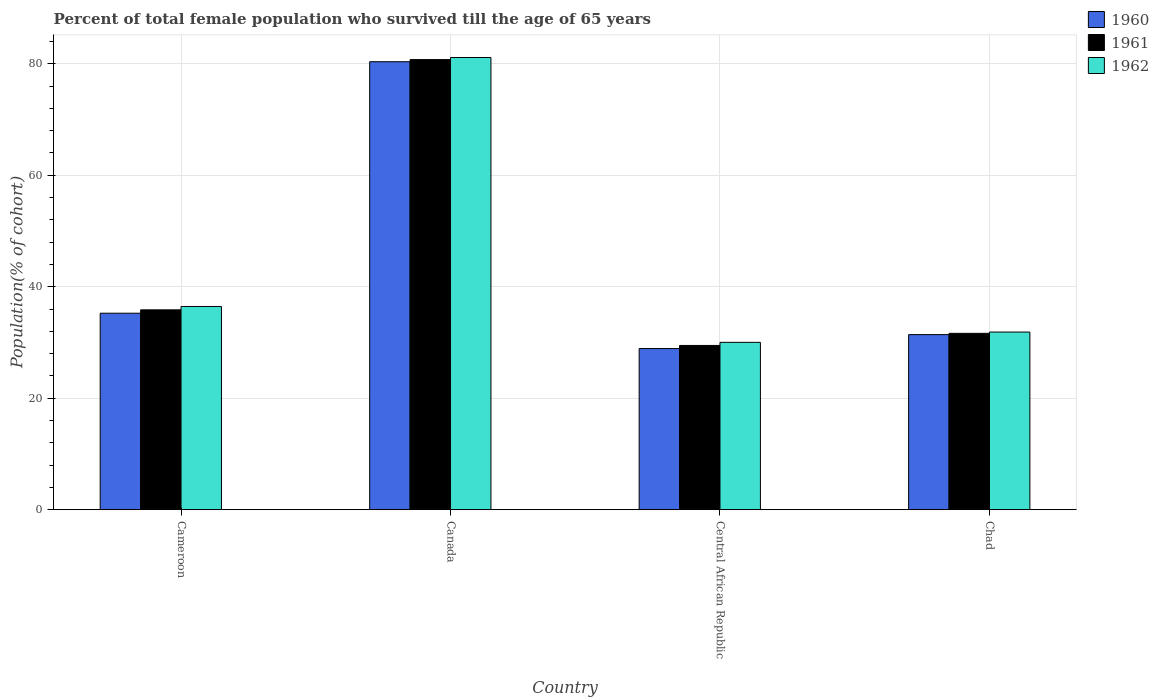How many different coloured bars are there?
Your answer should be compact. 3. How many groups of bars are there?
Your answer should be very brief. 4. How many bars are there on the 3rd tick from the left?
Ensure brevity in your answer.  3. How many bars are there on the 3rd tick from the right?
Ensure brevity in your answer.  3. What is the label of the 3rd group of bars from the left?
Keep it short and to the point. Central African Republic. In how many cases, is the number of bars for a given country not equal to the number of legend labels?
Make the answer very short. 0. What is the percentage of total female population who survived till the age of 65 years in 1961 in Central African Republic?
Ensure brevity in your answer.  29.47. Across all countries, what is the maximum percentage of total female population who survived till the age of 65 years in 1960?
Offer a terse response. 80.38. Across all countries, what is the minimum percentage of total female population who survived till the age of 65 years in 1961?
Ensure brevity in your answer.  29.47. In which country was the percentage of total female population who survived till the age of 65 years in 1960 minimum?
Make the answer very short. Central African Republic. What is the total percentage of total female population who survived till the age of 65 years in 1962 in the graph?
Provide a succinct answer. 179.5. What is the difference between the percentage of total female population who survived till the age of 65 years in 1961 in Cameroon and that in Central African Republic?
Your response must be concise. 6.39. What is the difference between the percentage of total female population who survived till the age of 65 years in 1960 in Chad and the percentage of total female population who survived till the age of 65 years in 1961 in Cameroon?
Make the answer very short. -4.44. What is the average percentage of total female population who survived till the age of 65 years in 1961 per country?
Offer a terse response. 44.43. What is the difference between the percentage of total female population who survived till the age of 65 years of/in 1960 and percentage of total female population who survived till the age of 65 years of/in 1962 in Cameroon?
Offer a terse response. -1.21. In how many countries, is the percentage of total female population who survived till the age of 65 years in 1961 greater than 12 %?
Your answer should be very brief. 4. What is the ratio of the percentage of total female population who survived till the age of 65 years in 1961 in Central African Republic to that in Chad?
Your answer should be very brief. 0.93. Is the percentage of total female population who survived till the age of 65 years in 1962 in Canada less than that in Chad?
Your answer should be compact. No. Is the difference between the percentage of total female population who survived till the age of 65 years in 1960 in Cameroon and Chad greater than the difference between the percentage of total female population who survived till the age of 65 years in 1962 in Cameroon and Chad?
Provide a succinct answer. No. What is the difference between the highest and the second highest percentage of total female population who survived till the age of 65 years in 1962?
Your answer should be compact. 44.67. What is the difference between the highest and the lowest percentage of total female population who survived till the age of 65 years in 1961?
Keep it short and to the point. 51.29. In how many countries, is the percentage of total female population who survived till the age of 65 years in 1960 greater than the average percentage of total female population who survived till the age of 65 years in 1960 taken over all countries?
Offer a very short reply. 1. Is the sum of the percentage of total female population who survived till the age of 65 years in 1962 in Cameroon and Canada greater than the maximum percentage of total female population who survived till the age of 65 years in 1960 across all countries?
Ensure brevity in your answer.  Yes. What does the 2nd bar from the left in Canada represents?
Your response must be concise. 1961. Are all the bars in the graph horizontal?
Make the answer very short. No. What is the difference between two consecutive major ticks on the Y-axis?
Keep it short and to the point. 20. Are the values on the major ticks of Y-axis written in scientific E-notation?
Your answer should be compact. No. Where does the legend appear in the graph?
Make the answer very short. Top right. How many legend labels are there?
Keep it short and to the point. 3. How are the legend labels stacked?
Ensure brevity in your answer.  Vertical. What is the title of the graph?
Keep it short and to the point. Percent of total female population who survived till the age of 65 years. What is the label or title of the X-axis?
Make the answer very short. Country. What is the label or title of the Y-axis?
Your response must be concise. Population(% of cohort). What is the Population(% of cohort) in 1960 in Cameroon?
Provide a succinct answer. 35.25. What is the Population(% of cohort) of 1961 in Cameroon?
Make the answer very short. 35.86. What is the Population(% of cohort) of 1962 in Cameroon?
Your answer should be compact. 36.46. What is the Population(% of cohort) in 1960 in Canada?
Your answer should be compact. 80.38. What is the Population(% of cohort) in 1961 in Canada?
Ensure brevity in your answer.  80.76. What is the Population(% of cohort) in 1962 in Canada?
Give a very brief answer. 81.14. What is the Population(% of cohort) in 1960 in Central African Republic?
Provide a short and direct response. 28.91. What is the Population(% of cohort) of 1961 in Central African Republic?
Your response must be concise. 29.47. What is the Population(% of cohort) of 1962 in Central African Republic?
Offer a very short reply. 30.03. What is the Population(% of cohort) in 1960 in Chad?
Offer a terse response. 31.41. What is the Population(% of cohort) of 1961 in Chad?
Ensure brevity in your answer.  31.64. What is the Population(% of cohort) in 1962 in Chad?
Offer a terse response. 31.87. Across all countries, what is the maximum Population(% of cohort) in 1960?
Your answer should be compact. 80.38. Across all countries, what is the maximum Population(% of cohort) in 1961?
Offer a very short reply. 80.76. Across all countries, what is the maximum Population(% of cohort) of 1962?
Offer a terse response. 81.14. Across all countries, what is the minimum Population(% of cohort) in 1960?
Your answer should be very brief. 28.91. Across all countries, what is the minimum Population(% of cohort) in 1961?
Your answer should be very brief. 29.47. Across all countries, what is the minimum Population(% of cohort) in 1962?
Make the answer very short. 30.03. What is the total Population(% of cohort) of 1960 in the graph?
Your answer should be compact. 175.95. What is the total Population(% of cohort) in 1961 in the graph?
Offer a very short reply. 177.73. What is the total Population(% of cohort) of 1962 in the graph?
Your response must be concise. 179.5. What is the difference between the Population(% of cohort) of 1960 in Cameroon and that in Canada?
Your response must be concise. -45.12. What is the difference between the Population(% of cohort) of 1961 in Cameroon and that in Canada?
Your response must be concise. -44.9. What is the difference between the Population(% of cohort) in 1962 in Cameroon and that in Canada?
Provide a succinct answer. -44.67. What is the difference between the Population(% of cohort) in 1960 in Cameroon and that in Central African Republic?
Give a very brief answer. 6.34. What is the difference between the Population(% of cohort) of 1961 in Cameroon and that in Central African Republic?
Ensure brevity in your answer.  6.39. What is the difference between the Population(% of cohort) of 1962 in Cameroon and that in Central African Republic?
Your answer should be compact. 6.43. What is the difference between the Population(% of cohort) of 1960 in Cameroon and that in Chad?
Your answer should be compact. 3.84. What is the difference between the Population(% of cohort) of 1961 in Cameroon and that in Chad?
Your response must be concise. 4.21. What is the difference between the Population(% of cohort) of 1962 in Cameroon and that in Chad?
Make the answer very short. 4.59. What is the difference between the Population(% of cohort) in 1960 in Canada and that in Central African Republic?
Provide a short and direct response. 51.46. What is the difference between the Population(% of cohort) of 1961 in Canada and that in Central African Republic?
Your response must be concise. 51.29. What is the difference between the Population(% of cohort) in 1962 in Canada and that in Central African Republic?
Your answer should be very brief. 51.11. What is the difference between the Population(% of cohort) of 1960 in Canada and that in Chad?
Give a very brief answer. 48.96. What is the difference between the Population(% of cohort) in 1961 in Canada and that in Chad?
Provide a short and direct response. 49.11. What is the difference between the Population(% of cohort) of 1962 in Canada and that in Chad?
Your answer should be compact. 49.26. What is the difference between the Population(% of cohort) of 1960 in Central African Republic and that in Chad?
Your answer should be very brief. -2.5. What is the difference between the Population(% of cohort) of 1961 in Central African Republic and that in Chad?
Provide a short and direct response. -2.17. What is the difference between the Population(% of cohort) of 1962 in Central African Republic and that in Chad?
Ensure brevity in your answer.  -1.84. What is the difference between the Population(% of cohort) in 1960 in Cameroon and the Population(% of cohort) in 1961 in Canada?
Offer a terse response. -45.5. What is the difference between the Population(% of cohort) of 1960 in Cameroon and the Population(% of cohort) of 1962 in Canada?
Your answer should be very brief. -45.88. What is the difference between the Population(% of cohort) of 1961 in Cameroon and the Population(% of cohort) of 1962 in Canada?
Ensure brevity in your answer.  -45.28. What is the difference between the Population(% of cohort) of 1960 in Cameroon and the Population(% of cohort) of 1961 in Central African Republic?
Make the answer very short. 5.78. What is the difference between the Population(% of cohort) in 1960 in Cameroon and the Population(% of cohort) in 1962 in Central African Republic?
Give a very brief answer. 5.22. What is the difference between the Population(% of cohort) in 1961 in Cameroon and the Population(% of cohort) in 1962 in Central African Republic?
Provide a short and direct response. 5.83. What is the difference between the Population(% of cohort) of 1960 in Cameroon and the Population(% of cohort) of 1961 in Chad?
Ensure brevity in your answer.  3.61. What is the difference between the Population(% of cohort) of 1960 in Cameroon and the Population(% of cohort) of 1962 in Chad?
Your answer should be compact. 3.38. What is the difference between the Population(% of cohort) in 1961 in Cameroon and the Population(% of cohort) in 1962 in Chad?
Give a very brief answer. 3.98. What is the difference between the Population(% of cohort) in 1960 in Canada and the Population(% of cohort) in 1961 in Central African Republic?
Ensure brevity in your answer.  50.91. What is the difference between the Population(% of cohort) in 1960 in Canada and the Population(% of cohort) in 1962 in Central African Republic?
Keep it short and to the point. 50.35. What is the difference between the Population(% of cohort) in 1961 in Canada and the Population(% of cohort) in 1962 in Central African Republic?
Offer a terse response. 50.73. What is the difference between the Population(% of cohort) in 1960 in Canada and the Population(% of cohort) in 1961 in Chad?
Your answer should be very brief. 48.73. What is the difference between the Population(% of cohort) in 1960 in Canada and the Population(% of cohort) in 1962 in Chad?
Your response must be concise. 48.5. What is the difference between the Population(% of cohort) in 1961 in Canada and the Population(% of cohort) in 1962 in Chad?
Your answer should be very brief. 48.88. What is the difference between the Population(% of cohort) of 1960 in Central African Republic and the Population(% of cohort) of 1961 in Chad?
Offer a terse response. -2.73. What is the difference between the Population(% of cohort) in 1960 in Central African Republic and the Population(% of cohort) in 1962 in Chad?
Your answer should be very brief. -2.96. What is the difference between the Population(% of cohort) of 1961 in Central African Republic and the Population(% of cohort) of 1962 in Chad?
Provide a short and direct response. -2.4. What is the average Population(% of cohort) of 1960 per country?
Your answer should be compact. 43.99. What is the average Population(% of cohort) in 1961 per country?
Your answer should be compact. 44.43. What is the average Population(% of cohort) of 1962 per country?
Ensure brevity in your answer.  44.87. What is the difference between the Population(% of cohort) in 1960 and Population(% of cohort) in 1961 in Cameroon?
Offer a very short reply. -0.6. What is the difference between the Population(% of cohort) of 1960 and Population(% of cohort) of 1962 in Cameroon?
Make the answer very short. -1.21. What is the difference between the Population(% of cohort) in 1961 and Population(% of cohort) in 1962 in Cameroon?
Make the answer very short. -0.6. What is the difference between the Population(% of cohort) of 1960 and Population(% of cohort) of 1961 in Canada?
Your response must be concise. -0.38. What is the difference between the Population(% of cohort) of 1960 and Population(% of cohort) of 1962 in Canada?
Your response must be concise. -0.76. What is the difference between the Population(% of cohort) of 1961 and Population(% of cohort) of 1962 in Canada?
Your answer should be compact. -0.38. What is the difference between the Population(% of cohort) in 1960 and Population(% of cohort) in 1961 in Central African Republic?
Your response must be concise. -0.56. What is the difference between the Population(% of cohort) in 1960 and Population(% of cohort) in 1962 in Central African Republic?
Keep it short and to the point. -1.12. What is the difference between the Population(% of cohort) of 1961 and Population(% of cohort) of 1962 in Central African Republic?
Your response must be concise. -0.56. What is the difference between the Population(% of cohort) of 1960 and Population(% of cohort) of 1961 in Chad?
Your answer should be compact. -0.23. What is the difference between the Population(% of cohort) in 1960 and Population(% of cohort) in 1962 in Chad?
Your answer should be compact. -0.46. What is the difference between the Population(% of cohort) in 1961 and Population(% of cohort) in 1962 in Chad?
Give a very brief answer. -0.23. What is the ratio of the Population(% of cohort) in 1960 in Cameroon to that in Canada?
Offer a very short reply. 0.44. What is the ratio of the Population(% of cohort) in 1961 in Cameroon to that in Canada?
Give a very brief answer. 0.44. What is the ratio of the Population(% of cohort) in 1962 in Cameroon to that in Canada?
Give a very brief answer. 0.45. What is the ratio of the Population(% of cohort) of 1960 in Cameroon to that in Central African Republic?
Make the answer very short. 1.22. What is the ratio of the Population(% of cohort) of 1961 in Cameroon to that in Central African Republic?
Offer a terse response. 1.22. What is the ratio of the Population(% of cohort) in 1962 in Cameroon to that in Central African Republic?
Offer a terse response. 1.21. What is the ratio of the Population(% of cohort) of 1960 in Cameroon to that in Chad?
Offer a terse response. 1.12. What is the ratio of the Population(% of cohort) of 1961 in Cameroon to that in Chad?
Make the answer very short. 1.13. What is the ratio of the Population(% of cohort) in 1962 in Cameroon to that in Chad?
Offer a terse response. 1.14. What is the ratio of the Population(% of cohort) of 1960 in Canada to that in Central African Republic?
Make the answer very short. 2.78. What is the ratio of the Population(% of cohort) of 1961 in Canada to that in Central African Republic?
Provide a short and direct response. 2.74. What is the ratio of the Population(% of cohort) in 1962 in Canada to that in Central African Republic?
Your response must be concise. 2.7. What is the ratio of the Population(% of cohort) in 1960 in Canada to that in Chad?
Your answer should be very brief. 2.56. What is the ratio of the Population(% of cohort) in 1961 in Canada to that in Chad?
Your answer should be compact. 2.55. What is the ratio of the Population(% of cohort) of 1962 in Canada to that in Chad?
Provide a short and direct response. 2.55. What is the ratio of the Population(% of cohort) in 1960 in Central African Republic to that in Chad?
Keep it short and to the point. 0.92. What is the ratio of the Population(% of cohort) in 1961 in Central African Republic to that in Chad?
Give a very brief answer. 0.93. What is the ratio of the Population(% of cohort) of 1962 in Central African Republic to that in Chad?
Ensure brevity in your answer.  0.94. What is the difference between the highest and the second highest Population(% of cohort) in 1960?
Keep it short and to the point. 45.12. What is the difference between the highest and the second highest Population(% of cohort) in 1961?
Provide a short and direct response. 44.9. What is the difference between the highest and the second highest Population(% of cohort) in 1962?
Provide a short and direct response. 44.67. What is the difference between the highest and the lowest Population(% of cohort) in 1960?
Provide a succinct answer. 51.46. What is the difference between the highest and the lowest Population(% of cohort) in 1961?
Your answer should be compact. 51.29. What is the difference between the highest and the lowest Population(% of cohort) of 1962?
Give a very brief answer. 51.11. 